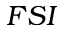<formula> <loc_0><loc_0><loc_500><loc_500>F S I</formula> 